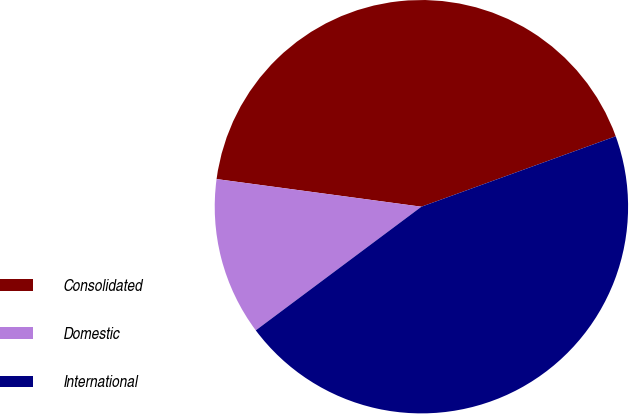<chart> <loc_0><loc_0><loc_500><loc_500><pie_chart><fcel>Consolidated<fcel>Domestic<fcel>International<nl><fcel>42.33%<fcel>12.34%<fcel>45.33%<nl></chart> 